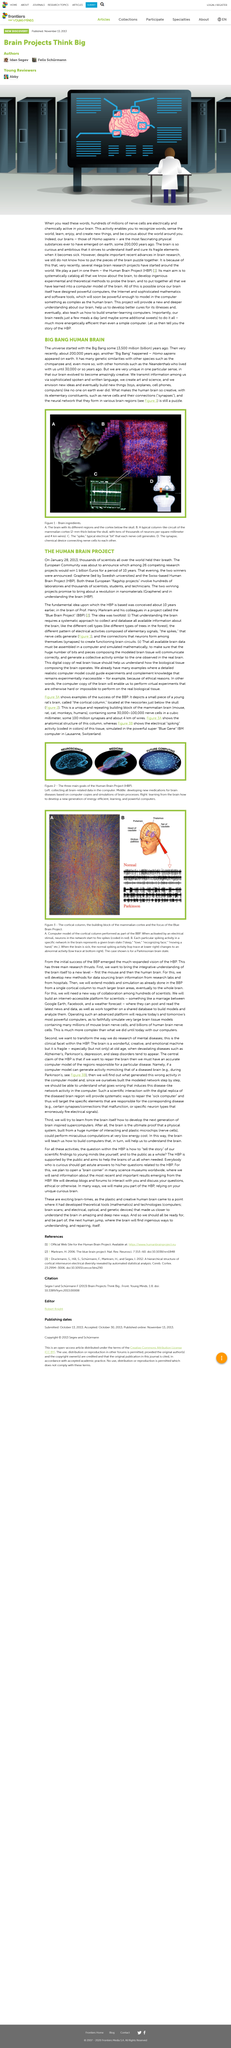Mention a couple of crucial points in this snapshot. Another example of a hominid is the Neanderthals, a species of human-like primates that lived during the Ice Age. The universe began with the Big Bang. The winning of the research project by the European Community was rewarded with a prize of one billion Euros for a period of ten years. Homo sapiens appeared on earth 200,000 years ago. Human Brain Project (HBP) is the abbreviation for the article's topic. 